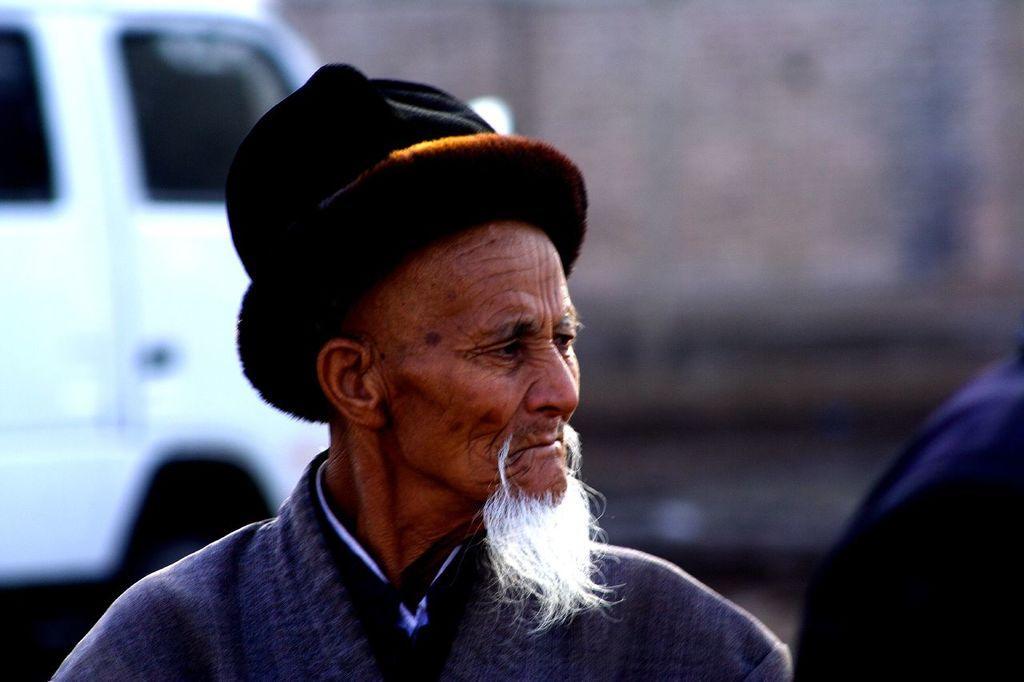Describe this image in one or two sentences. In the center of the image we can see a man. He is wearing a cap. In the background there is a vehicle. On the right there is a person. 